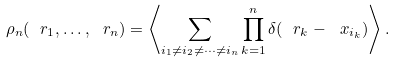Convert formula to latex. <formula><loc_0><loc_0><loc_500><loc_500>\rho _ { n } ( \ r _ { 1 } , \dots , \ r _ { n } ) = \left \langle \sum _ { i _ { 1 } \ne i _ { 2 } \ne \cdots \ne i _ { n } } \prod _ { k = 1 } ^ { n } \delta ( \ r _ { k } - \ x _ { i _ { k } } ) \right \rangle .</formula> 